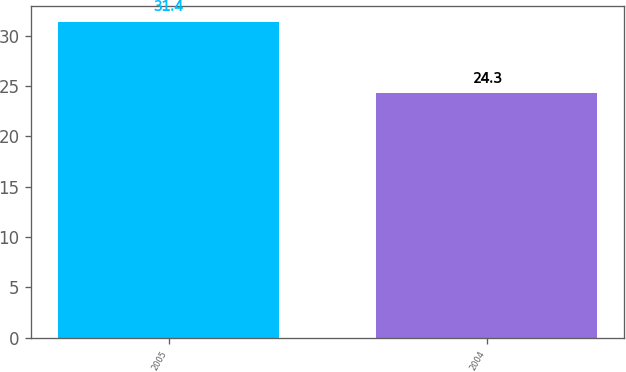Convert chart to OTSL. <chart><loc_0><loc_0><loc_500><loc_500><bar_chart><fcel>2005<fcel>2004<nl><fcel>31.4<fcel>24.3<nl></chart> 